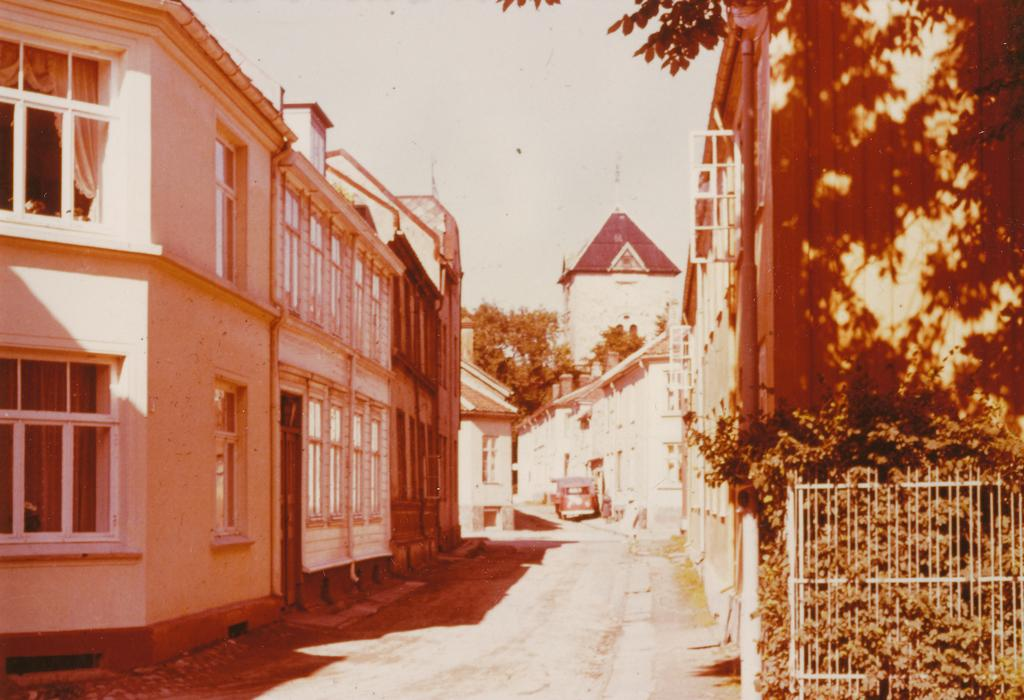What type of structures can be seen in the image? There are buildings in the image. What is separating the buildings from the road in the image? There is a fence in the image. What type of vegetation is present in the image? There are plants and trees in the image. What mode of transportation can be seen on the road in the image? There is a car on the road in the image. What is visible in the background of the image? The sky is visible in the background of the image. Where is the sister holding the silk meeting in the image? There is no sister, silk, or meeting present in the image. 